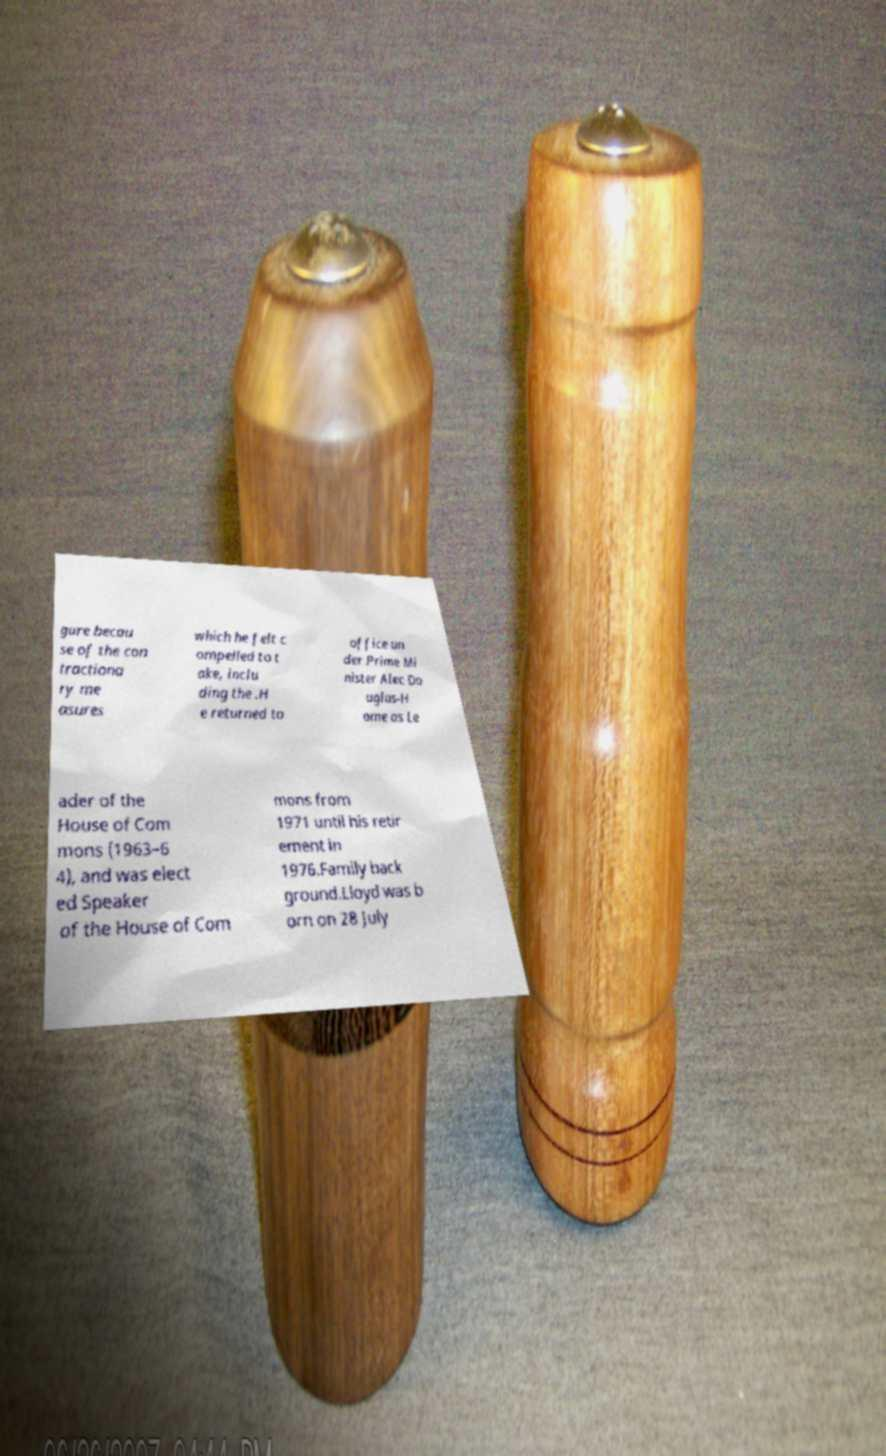I need the written content from this picture converted into text. Can you do that? gure becau se of the con tractiona ry me asures which he felt c ompelled to t ake, inclu ding the .H e returned to office un der Prime Mi nister Alec Do uglas-H ome as Le ader of the House of Com mons (1963–6 4), and was elect ed Speaker of the House of Com mons from 1971 until his retir ement in 1976.Family back ground.Lloyd was b orn on 28 July 